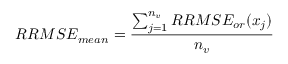Convert formula to latex. <formula><loc_0><loc_0><loc_500><loc_500>R R M S E _ { m e a n } = \frac { \sum _ { j = 1 } ^ { n _ { v } } R R M S E _ { o r } ( x _ { j } ) } { n _ { v } }</formula> 